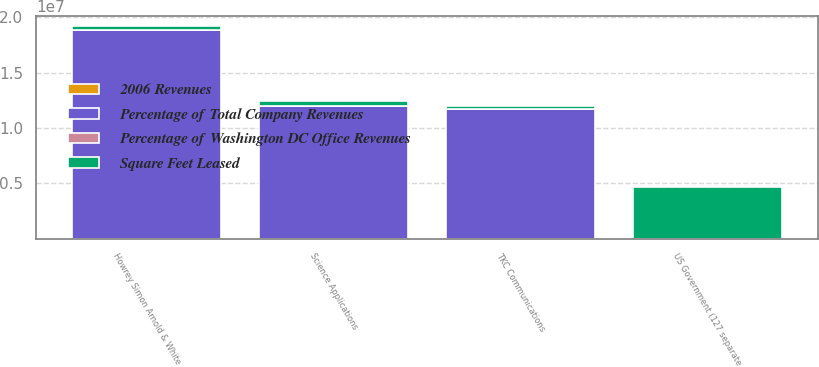Convert chart to OTSL. <chart><loc_0><loc_0><loc_500><loc_500><stacked_bar_chart><ecel><fcel>US Government (127 separate<fcel>Howrey Simon Arnold & White<fcel>Science Applications<fcel>TKC Communications<nl><fcel>Square Feet Leased<fcel>4.697e+06<fcel>317000<fcel>440000<fcel>309000<nl><fcel>Percentage of Total Company Revenues<fcel>25<fcel>1.8854e+07<fcel>1.2005e+07<fcel>1.1677e+07<nl><fcel>Percentage of Washington DC Office Revenues<fcel>25<fcel>4<fcel>2<fcel>2<nl><fcel>2006 Revenues<fcel>5<fcel>0.7<fcel>0.4<fcel>0.4<nl></chart> 